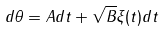<formula> <loc_0><loc_0><loc_500><loc_500>d \theta = A d t + \sqrt { B } \xi ( t ) d t</formula> 